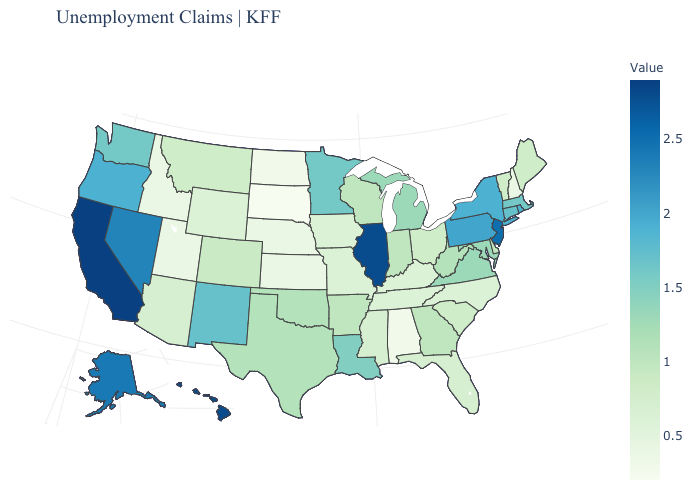Which states have the lowest value in the USA?
Give a very brief answer. South Dakota. Among the states that border Mississippi , which have the lowest value?
Concise answer only. Alabama. Which states have the lowest value in the Northeast?
Answer briefly. New Hampshire. 